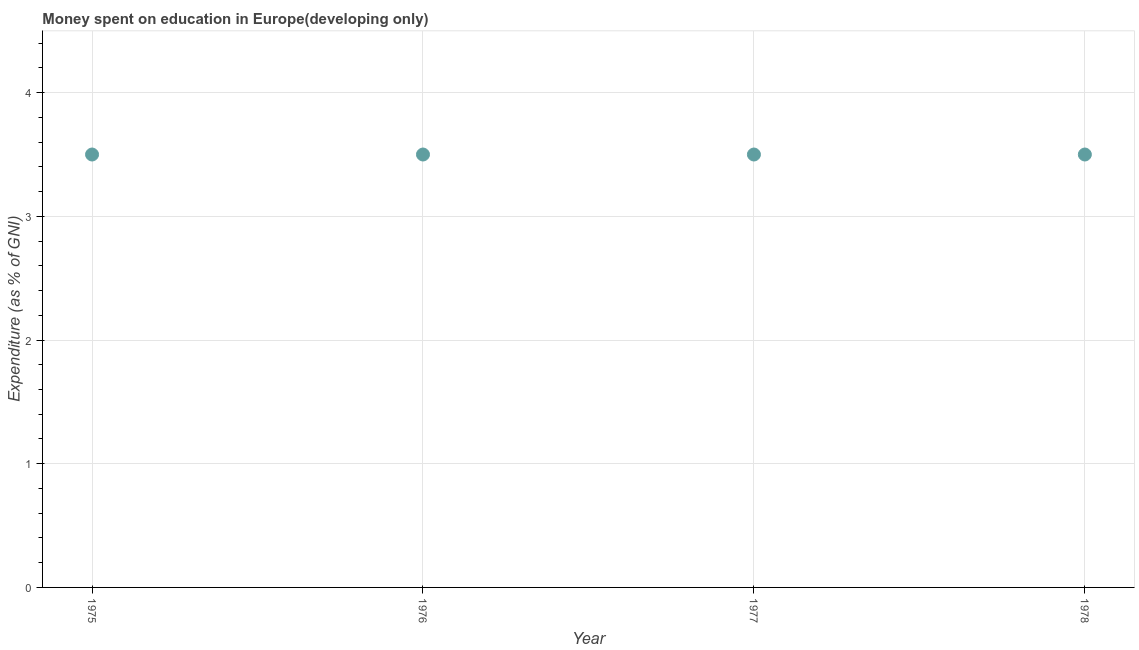What is the expenditure on education in 1975?
Your response must be concise. 3.5. Across all years, what is the maximum expenditure on education?
Ensure brevity in your answer.  3.5. Across all years, what is the minimum expenditure on education?
Make the answer very short. 3.5. In which year was the expenditure on education maximum?
Your answer should be compact. 1975. In which year was the expenditure on education minimum?
Your answer should be very brief. 1975. What is the sum of the expenditure on education?
Give a very brief answer. 14. What is the median expenditure on education?
Offer a terse response. 3.5. Do a majority of the years between 1978 and 1977 (inclusive) have expenditure on education greater than 3.4 %?
Provide a succinct answer. No. What is the ratio of the expenditure on education in 1977 to that in 1978?
Keep it short and to the point. 1. What is the difference between the highest and the lowest expenditure on education?
Your answer should be very brief. 0. In how many years, is the expenditure on education greater than the average expenditure on education taken over all years?
Offer a terse response. 0. How many years are there in the graph?
Offer a very short reply. 4. Are the values on the major ticks of Y-axis written in scientific E-notation?
Offer a very short reply. No. Does the graph contain any zero values?
Offer a terse response. No. Does the graph contain grids?
Offer a very short reply. Yes. What is the title of the graph?
Offer a terse response. Money spent on education in Europe(developing only). What is the label or title of the Y-axis?
Keep it short and to the point. Expenditure (as % of GNI). What is the Expenditure (as % of GNI) in 1975?
Offer a terse response. 3.5. What is the Expenditure (as % of GNI) in 1976?
Give a very brief answer. 3.5. What is the Expenditure (as % of GNI) in 1977?
Provide a succinct answer. 3.5. What is the Expenditure (as % of GNI) in 1978?
Ensure brevity in your answer.  3.5. What is the difference between the Expenditure (as % of GNI) in 1975 and 1976?
Ensure brevity in your answer.  0. What is the difference between the Expenditure (as % of GNI) in 1975 and 1977?
Make the answer very short. 0. What is the difference between the Expenditure (as % of GNI) in 1976 and 1977?
Make the answer very short. 0. What is the difference between the Expenditure (as % of GNI) in 1976 and 1978?
Keep it short and to the point. 0. What is the difference between the Expenditure (as % of GNI) in 1977 and 1978?
Provide a succinct answer. 0. What is the ratio of the Expenditure (as % of GNI) in 1976 to that in 1977?
Keep it short and to the point. 1. What is the ratio of the Expenditure (as % of GNI) in 1976 to that in 1978?
Your response must be concise. 1. What is the ratio of the Expenditure (as % of GNI) in 1977 to that in 1978?
Your answer should be very brief. 1. 